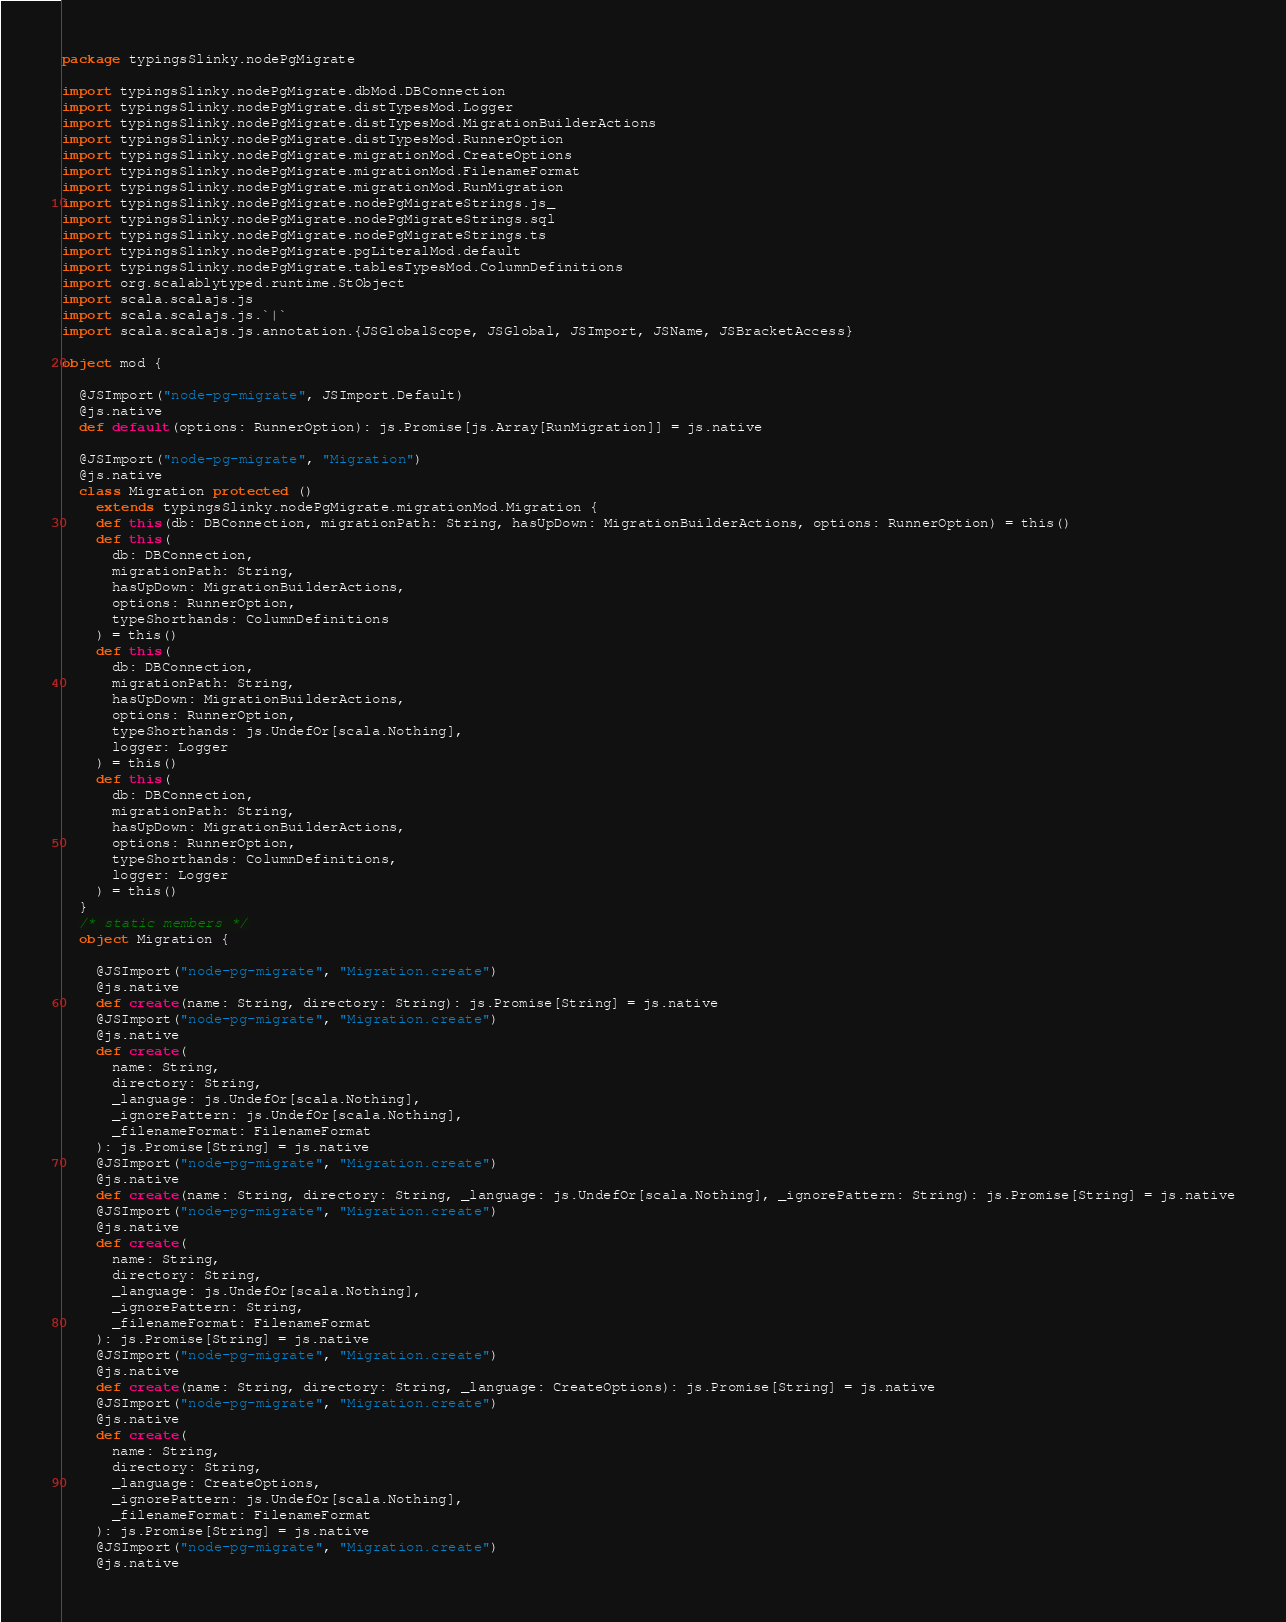<code> <loc_0><loc_0><loc_500><loc_500><_Scala_>package typingsSlinky.nodePgMigrate

import typingsSlinky.nodePgMigrate.dbMod.DBConnection
import typingsSlinky.nodePgMigrate.distTypesMod.Logger
import typingsSlinky.nodePgMigrate.distTypesMod.MigrationBuilderActions
import typingsSlinky.nodePgMigrate.distTypesMod.RunnerOption
import typingsSlinky.nodePgMigrate.migrationMod.CreateOptions
import typingsSlinky.nodePgMigrate.migrationMod.FilenameFormat
import typingsSlinky.nodePgMigrate.migrationMod.RunMigration
import typingsSlinky.nodePgMigrate.nodePgMigrateStrings.js_
import typingsSlinky.nodePgMigrate.nodePgMigrateStrings.sql
import typingsSlinky.nodePgMigrate.nodePgMigrateStrings.ts
import typingsSlinky.nodePgMigrate.pgLiteralMod.default
import typingsSlinky.nodePgMigrate.tablesTypesMod.ColumnDefinitions
import org.scalablytyped.runtime.StObject
import scala.scalajs.js
import scala.scalajs.js.`|`
import scala.scalajs.js.annotation.{JSGlobalScope, JSGlobal, JSImport, JSName, JSBracketAccess}

object mod {
  
  @JSImport("node-pg-migrate", JSImport.Default)
  @js.native
  def default(options: RunnerOption): js.Promise[js.Array[RunMigration]] = js.native
  
  @JSImport("node-pg-migrate", "Migration")
  @js.native
  class Migration protected ()
    extends typingsSlinky.nodePgMigrate.migrationMod.Migration {
    def this(db: DBConnection, migrationPath: String, hasUpDown: MigrationBuilderActions, options: RunnerOption) = this()
    def this(
      db: DBConnection,
      migrationPath: String,
      hasUpDown: MigrationBuilderActions,
      options: RunnerOption,
      typeShorthands: ColumnDefinitions
    ) = this()
    def this(
      db: DBConnection,
      migrationPath: String,
      hasUpDown: MigrationBuilderActions,
      options: RunnerOption,
      typeShorthands: js.UndefOr[scala.Nothing],
      logger: Logger
    ) = this()
    def this(
      db: DBConnection,
      migrationPath: String,
      hasUpDown: MigrationBuilderActions,
      options: RunnerOption,
      typeShorthands: ColumnDefinitions,
      logger: Logger
    ) = this()
  }
  /* static members */
  object Migration {
    
    @JSImport("node-pg-migrate", "Migration.create")
    @js.native
    def create(name: String, directory: String): js.Promise[String] = js.native
    @JSImport("node-pg-migrate", "Migration.create")
    @js.native
    def create(
      name: String,
      directory: String,
      _language: js.UndefOr[scala.Nothing],
      _ignorePattern: js.UndefOr[scala.Nothing],
      _filenameFormat: FilenameFormat
    ): js.Promise[String] = js.native
    @JSImport("node-pg-migrate", "Migration.create")
    @js.native
    def create(name: String, directory: String, _language: js.UndefOr[scala.Nothing], _ignorePattern: String): js.Promise[String] = js.native
    @JSImport("node-pg-migrate", "Migration.create")
    @js.native
    def create(
      name: String,
      directory: String,
      _language: js.UndefOr[scala.Nothing],
      _ignorePattern: String,
      _filenameFormat: FilenameFormat
    ): js.Promise[String] = js.native
    @JSImport("node-pg-migrate", "Migration.create")
    @js.native
    def create(name: String, directory: String, _language: CreateOptions): js.Promise[String] = js.native
    @JSImport("node-pg-migrate", "Migration.create")
    @js.native
    def create(
      name: String,
      directory: String,
      _language: CreateOptions,
      _ignorePattern: js.UndefOr[scala.Nothing],
      _filenameFormat: FilenameFormat
    ): js.Promise[String] = js.native
    @JSImport("node-pg-migrate", "Migration.create")
    @js.native</code> 